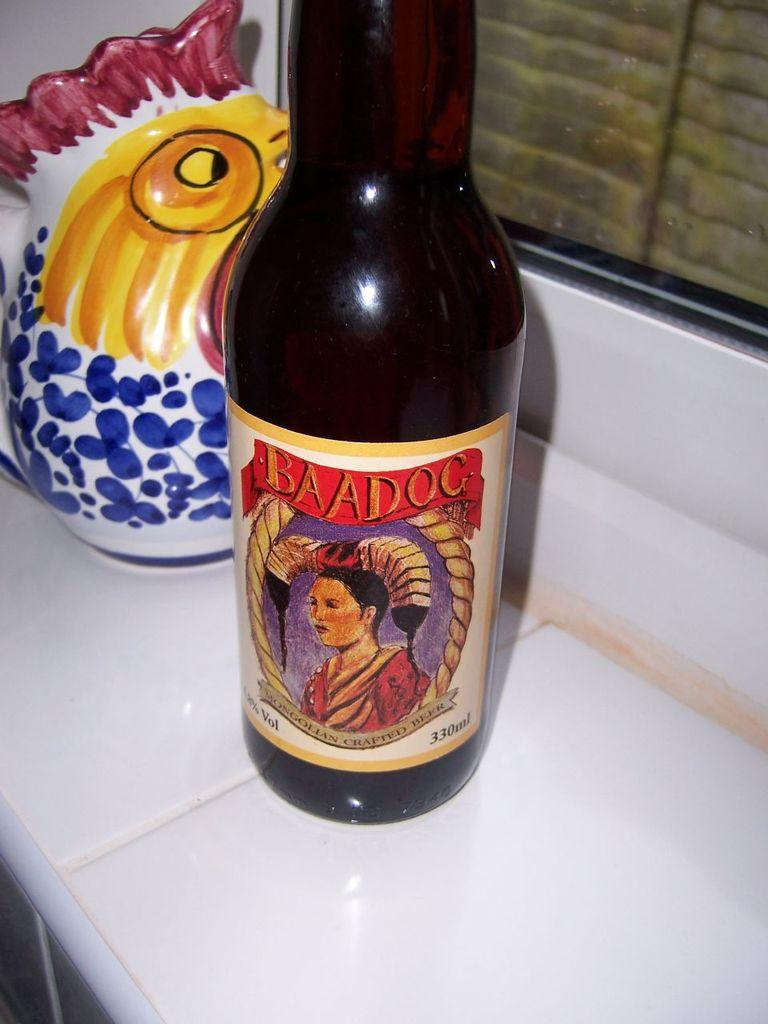<image>
Share a concise interpretation of the image provided. Baadog beer bottle showing a woman with long hair. 